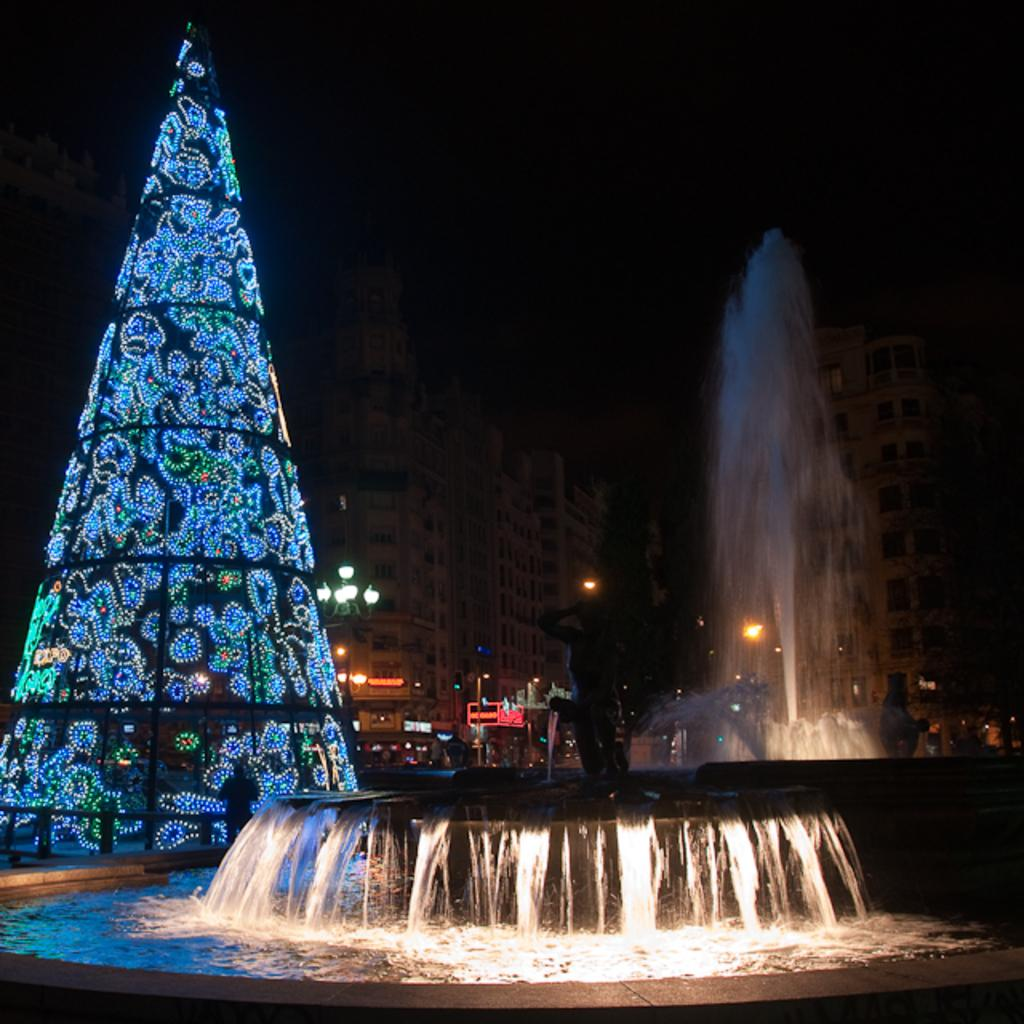What can be seen in the background of the image? In the background of the image, there are water fountains, an object covered with lights, light poles, buildings, and a dark sky. Can you describe the object covered with lights? The object covered with lights is not specifically described in the facts, but it is visible in the background of the image. What type of structures are present in the background of the image? The structures in the background of the image include light poles and buildings. How would you describe the lighting conditions in the image? The sky is dark in the background of the image, which suggests that it might be nighttime or overcast. Can you tell me how many mittens are hanging on the light poles in the image? There are no mittens present in the image; the light poles are not described as having any mittens hanging on them. What type of pig can be seen interacting with the water fountains in the image? There are no pigs present in the image; the water fountains are not described as having any pigs interacting with them. 